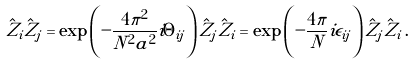Convert formula to latex. <formula><loc_0><loc_0><loc_500><loc_500>\hat { Z } _ { i } \hat { Z } _ { j } = \exp \left ( - \frac { 4 \pi ^ { 2 } } { N ^ { 2 } a ^ { 2 } } i \Theta _ { i j } \right ) \hat { Z } _ { j } \hat { Z } _ { i } = \exp \left ( - \frac { 4 \pi } { N } i \epsilon _ { i j } \right ) \hat { Z } _ { j } \hat { Z } _ { i } \, .</formula> 